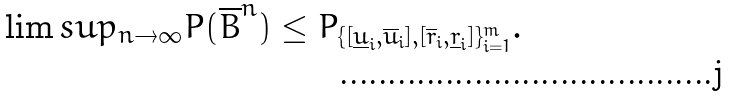Convert formula to latex. <formula><loc_0><loc_0><loc_500><loc_500>\lim s u p _ { n \to \infty } P ( \overline { B } ^ { n } ) \leq P _ { \{ [ \underline { u } _ { i } , \overline { u } _ { i } ] , [ \overline { r } _ { i } , \underline { r } _ { i } ] \} _ { i = 1 } ^ { m } } .</formula> 